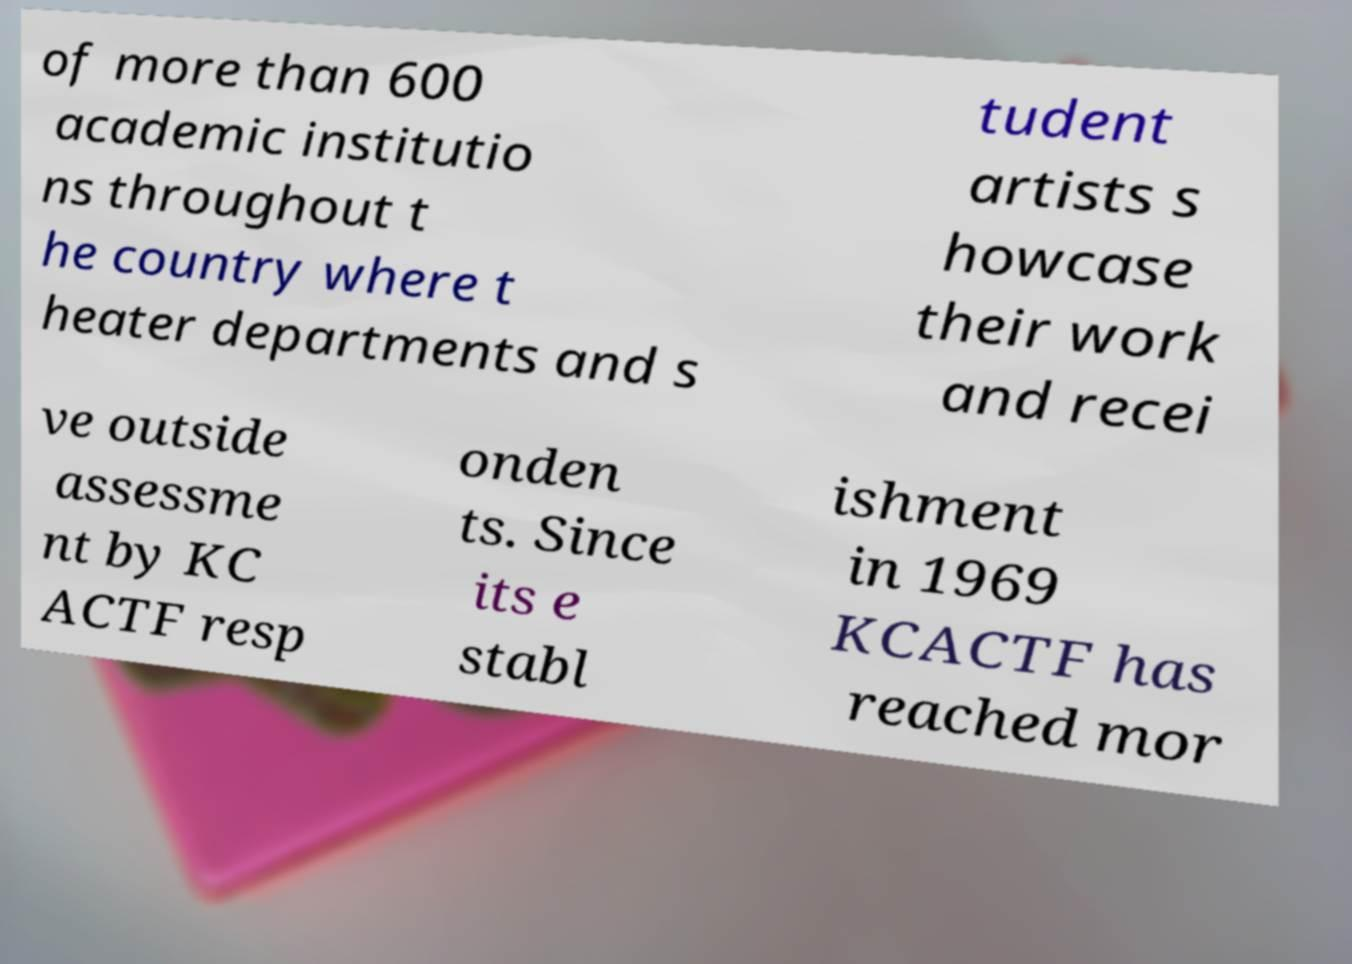Could you assist in decoding the text presented in this image and type it out clearly? of more than 600 academic institutio ns throughout t he country where t heater departments and s tudent artists s howcase their work and recei ve outside assessme nt by KC ACTF resp onden ts. Since its e stabl ishment in 1969 KCACTF has reached mor 